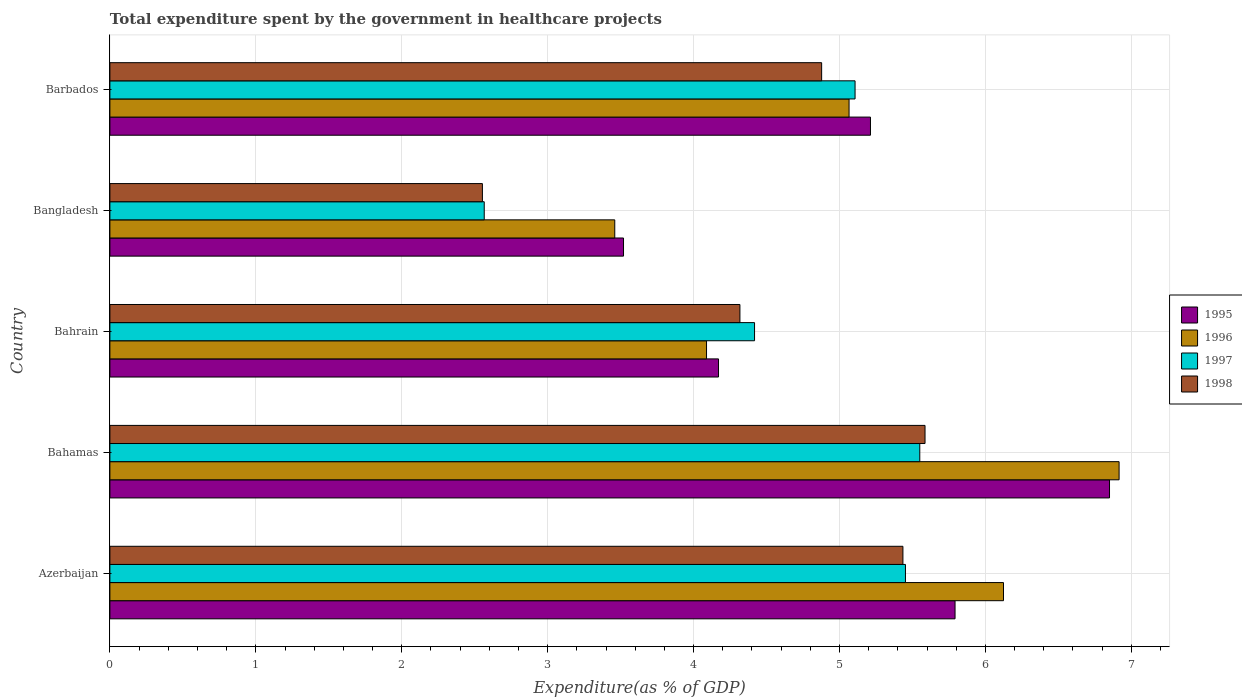Are the number of bars per tick equal to the number of legend labels?
Give a very brief answer. Yes. What is the label of the 4th group of bars from the top?
Offer a very short reply. Bahamas. What is the total expenditure spent by the government in healthcare projects in 1998 in Azerbaijan?
Your answer should be compact. 5.43. Across all countries, what is the maximum total expenditure spent by the government in healthcare projects in 1996?
Provide a short and direct response. 6.92. Across all countries, what is the minimum total expenditure spent by the government in healthcare projects in 1995?
Provide a succinct answer. 3.52. In which country was the total expenditure spent by the government in healthcare projects in 1998 maximum?
Ensure brevity in your answer.  Bahamas. What is the total total expenditure spent by the government in healthcare projects in 1998 in the graph?
Offer a terse response. 22.77. What is the difference between the total expenditure spent by the government in healthcare projects in 1995 in Bahamas and that in Barbados?
Make the answer very short. 1.64. What is the difference between the total expenditure spent by the government in healthcare projects in 1998 in Azerbaijan and the total expenditure spent by the government in healthcare projects in 1995 in Barbados?
Ensure brevity in your answer.  0.22. What is the average total expenditure spent by the government in healthcare projects in 1998 per country?
Provide a short and direct response. 4.55. What is the difference between the total expenditure spent by the government in healthcare projects in 1995 and total expenditure spent by the government in healthcare projects in 1996 in Bahamas?
Make the answer very short. -0.07. In how many countries, is the total expenditure spent by the government in healthcare projects in 1998 greater than 5.6 %?
Provide a short and direct response. 0. What is the ratio of the total expenditure spent by the government in healthcare projects in 1998 in Bahamas to that in Barbados?
Your answer should be very brief. 1.15. Is the total expenditure spent by the government in healthcare projects in 1996 in Bangladesh less than that in Barbados?
Offer a very short reply. Yes. What is the difference between the highest and the second highest total expenditure spent by the government in healthcare projects in 1997?
Provide a succinct answer. 0.1. What is the difference between the highest and the lowest total expenditure spent by the government in healthcare projects in 1995?
Offer a very short reply. 3.33. How many bars are there?
Offer a terse response. 20. Are the values on the major ticks of X-axis written in scientific E-notation?
Make the answer very short. No. Does the graph contain any zero values?
Keep it short and to the point. No. Where does the legend appear in the graph?
Your response must be concise. Center right. How many legend labels are there?
Provide a succinct answer. 4. How are the legend labels stacked?
Offer a very short reply. Vertical. What is the title of the graph?
Keep it short and to the point. Total expenditure spent by the government in healthcare projects. What is the label or title of the X-axis?
Offer a terse response. Expenditure(as % of GDP). What is the label or title of the Y-axis?
Keep it short and to the point. Country. What is the Expenditure(as % of GDP) in 1995 in Azerbaijan?
Provide a short and direct response. 5.79. What is the Expenditure(as % of GDP) in 1996 in Azerbaijan?
Offer a very short reply. 6.12. What is the Expenditure(as % of GDP) in 1997 in Azerbaijan?
Provide a succinct answer. 5.45. What is the Expenditure(as % of GDP) of 1998 in Azerbaijan?
Ensure brevity in your answer.  5.43. What is the Expenditure(as % of GDP) in 1995 in Bahamas?
Make the answer very short. 6.85. What is the Expenditure(as % of GDP) of 1996 in Bahamas?
Your response must be concise. 6.92. What is the Expenditure(as % of GDP) of 1997 in Bahamas?
Give a very brief answer. 5.55. What is the Expenditure(as % of GDP) in 1998 in Bahamas?
Ensure brevity in your answer.  5.59. What is the Expenditure(as % of GDP) of 1995 in Bahrain?
Offer a terse response. 4.17. What is the Expenditure(as % of GDP) of 1996 in Bahrain?
Ensure brevity in your answer.  4.09. What is the Expenditure(as % of GDP) in 1997 in Bahrain?
Keep it short and to the point. 4.42. What is the Expenditure(as % of GDP) of 1998 in Bahrain?
Your answer should be very brief. 4.32. What is the Expenditure(as % of GDP) of 1995 in Bangladesh?
Offer a very short reply. 3.52. What is the Expenditure(as % of GDP) in 1996 in Bangladesh?
Your response must be concise. 3.46. What is the Expenditure(as % of GDP) of 1997 in Bangladesh?
Make the answer very short. 2.57. What is the Expenditure(as % of GDP) in 1998 in Bangladesh?
Your answer should be very brief. 2.55. What is the Expenditure(as % of GDP) in 1995 in Barbados?
Your answer should be very brief. 5.21. What is the Expenditure(as % of GDP) of 1996 in Barbados?
Your answer should be very brief. 5.07. What is the Expenditure(as % of GDP) of 1997 in Barbados?
Your answer should be very brief. 5.11. What is the Expenditure(as % of GDP) of 1998 in Barbados?
Your answer should be very brief. 4.88. Across all countries, what is the maximum Expenditure(as % of GDP) in 1995?
Offer a terse response. 6.85. Across all countries, what is the maximum Expenditure(as % of GDP) of 1996?
Your response must be concise. 6.92. Across all countries, what is the maximum Expenditure(as % of GDP) of 1997?
Make the answer very short. 5.55. Across all countries, what is the maximum Expenditure(as % of GDP) of 1998?
Give a very brief answer. 5.59. Across all countries, what is the minimum Expenditure(as % of GDP) of 1995?
Your answer should be very brief. 3.52. Across all countries, what is the minimum Expenditure(as % of GDP) of 1996?
Keep it short and to the point. 3.46. Across all countries, what is the minimum Expenditure(as % of GDP) in 1997?
Your answer should be very brief. 2.57. Across all countries, what is the minimum Expenditure(as % of GDP) in 1998?
Your answer should be very brief. 2.55. What is the total Expenditure(as % of GDP) in 1995 in the graph?
Provide a short and direct response. 25.55. What is the total Expenditure(as % of GDP) in 1996 in the graph?
Your answer should be compact. 25.65. What is the total Expenditure(as % of GDP) in 1997 in the graph?
Ensure brevity in your answer.  23.09. What is the total Expenditure(as % of GDP) of 1998 in the graph?
Ensure brevity in your answer.  22.77. What is the difference between the Expenditure(as % of GDP) in 1995 in Azerbaijan and that in Bahamas?
Your answer should be compact. -1.06. What is the difference between the Expenditure(as % of GDP) in 1996 in Azerbaijan and that in Bahamas?
Offer a very short reply. -0.79. What is the difference between the Expenditure(as % of GDP) of 1997 in Azerbaijan and that in Bahamas?
Give a very brief answer. -0.1. What is the difference between the Expenditure(as % of GDP) of 1998 in Azerbaijan and that in Bahamas?
Your answer should be very brief. -0.15. What is the difference between the Expenditure(as % of GDP) of 1995 in Azerbaijan and that in Bahrain?
Provide a short and direct response. 1.62. What is the difference between the Expenditure(as % of GDP) in 1996 in Azerbaijan and that in Bahrain?
Your response must be concise. 2.04. What is the difference between the Expenditure(as % of GDP) in 1997 in Azerbaijan and that in Bahrain?
Provide a short and direct response. 1.03. What is the difference between the Expenditure(as % of GDP) of 1998 in Azerbaijan and that in Bahrain?
Give a very brief answer. 1.12. What is the difference between the Expenditure(as % of GDP) of 1995 in Azerbaijan and that in Bangladesh?
Ensure brevity in your answer.  2.27. What is the difference between the Expenditure(as % of GDP) in 1996 in Azerbaijan and that in Bangladesh?
Your response must be concise. 2.66. What is the difference between the Expenditure(as % of GDP) in 1997 in Azerbaijan and that in Bangladesh?
Your response must be concise. 2.89. What is the difference between the Expenditure(as % of GDP) of 1998 in Azerbaijan and that in Bangladesh?
Offer a terse response. 2.88. What is the difference between the Expenditure(as % of GDP) of 1995 in Azerbaijan and that in Barbados?
Make the answer very short. 0.58. What is the difference between the Expenditure(as % of GDP) of 1996 in Azerbaijan and that in Barbados?
Your answer should be compact. 1.06. What is the difference between the Expenditure(as % of GDP) in 1997 in Azerbaijan and that in Barbados?
Provide a succinct answer. 0.35. What is the difference between the Expenditure(as % of GDP) in 1998 in Azerbaijan and that in Barbados?
Give a very brief answer. 0.56. What is the difference between the Expenditure(as % of GDP) in 1995 in Bahamas and that in Bahrain?
Provide a short and direct response. 2.68. What is the difference between the Expenditure(as % of GDP) of 1996 in Bahamas and that in Bahrain?
Provide a succinct answer. 2.83. What is the difference between the Expenditure(as % of GDP) of 1997 in Bahamas and that in Bahrain?
Offer a terse response. 1.13. What is the difference between the Expenditure(as % of GDP) of 1998 in Bahamas and that in Bahrain?
Offer a very short reply. 1.27. What is the difference between the Expenditure(as % of GDP) in 1995 in Bahamas and that in Bangladesh?
Provide a short and direct response. 3.33. What is the difference between the Expenditure(as % of GDP) in 1996 in Bahamas and that in Bangladesh?
Your response must be concise. 3.46. What is the difference between the Expenditure(as % of GDP) in 1997 in Bahamas and that in Bangladesh?
Give a very brief answer. 2.98. What is the difference between the Expenditure(as % of GDP) in 1998 in Bahamas and that in Bangladesh?
Your response must be concise. 3.03. What is the difference between the Expenditure(as % of GDP) of 1995 in Bahamas and that in Barbados?
Keep it short and to the point. 1.64. What is the difference between the Expenditure(as % of GDP) in 1996 in Bahamas and that in Barbados?
Your answer should be compact. 1.85. What is the difference between the Expenditure(as % of GDP) of 1997 in Bahamas and that in Barbados?
Provide a succinct answer. 0.44. What is the difference between the Expenditure(as % of GDP) in 1998 in Bahamas and that in Barbados?
Provide a short and direct response. 0.71. What is the difference between the Expenditure(as % of GDP) of 1995 in Bahrain and that in Bangladesh?
Make the answer very short. 0.65. What is the difference between the Expenditure(as % of GDP) in 1996 in Bahrain and that in Bangladesh?
Your answer should be compact. 0.63. What is the difference between the Expenditure(as % of GDP) in 1997 in Bahrain and that in Bangladesh?
Provide a short and direct response. 1.85. What is the difference between the Expenditure(as % of GDP) of 1998 in Bahrain and that in Bangladesh?
Ensure brevity in your answer.  1.76. What is the difference between the Expenditure(as % of GDP) in 1995 in Bahrain and that in Barbados?
Offer a very short reply. -1.04. What is the difference between the Expenditure(as % of GDP) of 1996 in Bahrain and that in Barbados?
Your answer should be very brief. -0.98. What is the difference between the Expenditure(as % of GDP) in 1997 in Bahrain and that in Barbados?
Your answer should be very brief. -0.69. What is the difference between the Expenditure(as % of GDP) in 1998 in Bahrain and that in Barbados?
Give a very brief answer. -0.56. What is the difference between the Expenditure(as % of GDP) in 1995 in Bangladesh and that in Barbados?
Your response must be concise. -1.69. What is the difference between the Expenditure(as % of GDP) of 1996 in Bangladesh and that in Barbados?
Offer a very short reply. -1.61. What is the difference between the Expenditure(as % of GDP) in 1997 in Bangladesh and that in Barbados?
Your response must be concise. -2.54. What is the difference between the Expenditure(as % of GDP) of 1998 in Bangladesh and that in Barbados?
Give a very brief answer. -2.32. What is the difference between the Expenditure(as % of GDP) in 1995 in Azerbaijan and the Expenditure(as % of GDP) in 1996 in Bahamas?
Your answer should be compact. -1.12. What is the difference between the Expenditure(as % of GDP) in 1995 in Azerbaijan and the Expenditure(as % of GDP) in 1997 in Bahamas?
Offer a very short reply. 0.24. What is the difference between the Expenditure(as % of GDP) of 1995 in Azerbaijan and the Expenditure(as % of GDP) of 1998 in Bahamas?
Your answer should be very brief. 0.21. What is the difference between the Expenditure(as % of GDP) of 1996 in Azerbaijan and the Expenditure(as % of GDP) of 1997 in Bahamas?
Your response must be concise. 0.57. What is the difference between the Expenditure(as % of GDP) in 1996 in Azerbaijan and the Expenditure(as % of GDP) in 1998 in Bahamas?
Provide a short and direct response. 0.54. What is the difference between the Expenditure(as % of GDP) of 1997 in Azerbaijan and the Expenditure(as % of GDP) of 1998 in Bahamas?
Your response must be concise. -0.13. What is the difference between the Expenditure(as % of GDP) in 1995 in Azerbaijan and the Expenditure(as % of GDP) in 1996 in Bahrain?
Ensure brevity in your answer.  1.7. What is the difference between the Expenditure(as % of GDP) of 1995 in Azerbaijan and the Expenditure(as % of GDP) of 1997 in Bahrain?
Keep it short and to the point. 1.37. What is the difference between the Expenditure(as % of GDP) of 1995 in Azerbaijan and the Expenditure(as % of GDP) of 1998 in Bahrain?
Keep it short and to the point. 1.47. What is the difference between the Expenditure(as % of GDP) in 1996 in Azerbaijan and the Expenditure(as % of GDP) in 1997 in Bahrain?
Offer a terse response. 1.71. What is the difference between the Expenditure(as % of GDP) in 1996 in Azerbaijan and the Expenditure(as % of GDP) in 1998 in Bahrain?
Provide a succinct answer. 1.81. What is the difference between the Expenditure(as % of GDP) in 1997 in Azerbaijan and the Expenditure(as % of GDP) in 1998 in Bahrain?
Give a very brief answer. 1.13. What is the difference between the Expenditure(as % of GDP) in 1995 in Azerbaijan and the Expenditure(as % of GDP) in 1996 in Bangladesh?
Offer a very short reply. 2.33. What is the difference between the Expenditure(as % of GDP) of 1995 in Azerbaijan and the Expenditure(as % of GDP) of 1997 in Bangladesh?
Provide a succinct answer. 3.23. What is the difference between the Expenditure(as % of GDP) of 1995 in Azerbaijan and the Expenditure(as % of GDP) of 1998 in Bangladesh?
Give a very brief answer. 3.24. What is the difference between the Expenditure(as % of GDP) in 1996 in Azerbaijan and the Expenditure(as % of GDP) in 1997 in Bangladesh?
Your response must be concise. 3.56. What is the difference between the Expenditure(as % of GDP) in 1996 in Azerbaijan and the Expenditure(as % of GDP) in 1998 in Bangladesh?
Offer a very short reply. 3.57. What is the difference between the Expenditure(as % of GDP) in 1997 in Azerbaijan and the Expenditure(as % of GDP) in 1998 in Bangladesh?
Give a very brief answer. 2.9. What is the difference between the Expenditure(as % of GDP) of 1995 in Azerbaijan and the Expenditure(as % of GDP) of 1996 in Barbados?
Your answer should be very brief. 0.73. What is the difference between the Expenditure(as % of GDP) of 1995 in Azerbaijan and the Expenditure(as % of GDP) of 1997 in Barbados?
Keep it short and to the point. 0.69. What is the difference between the Expenditure(as % of GDP) of 1995 in Azerbaijan and the Expenditure(as % of GDP) of 1998 in Barbados?
Keep it short and to the point. 0.91. What is the difference between the Expenditure(as % of GDP) of 1996 in Azerbaijan and the Expenditure(as % of GDP) of 1997 in Barbados?
Offer a very short reply. 1.02. What is the difference between the Expenditure(as % of GDP) of 1996 in Azerbaijan and the Expenditure(as % of GDP) of 1998 in Barbados?
Your response must be concise. 1.25. What is the difference between the Expenditure(as % of GDP) of 1997 in Azerbaijan and the Expenditure(as % of GDP) of 1998 in Barbados?
Provide a succinct answer. 0.57. What is the difference between the Expenditure(as % of GDP) in 1995 in Bahamas and the Expenditure(as % of GDP) in 1996 in Bahrain?
Your answer should be compact. 2.76. What is the difference between the Expenditure(as % of GDP) in 1995 in Bahamas and the Expenditure(as % of GDP) in 1997 in Bahrain?
Make the answer very short. 2.43. What is the difference between the Expenditure(as % of GDP) of 1995 in Bahamas and the Expenditure(as % of GDP) of 1998 in Bahrain?
Provide a succinct answer. 2.53. What is the difference between the Expenditure(as % of GDP) of 1996 in Bahamas and the Expenditure(as % of GDP) of 1997 in Bahrain?
Provide a short and direct response. 2.5. What is the difference between the Expenditure(as % of GDP) of 1996 in Bahamas and the Expenditure(as % of GDP) of 1998 in Bahrain?
Give a very brief answer. 2.6. What is the difference between the Expenditure(as % of GDP) in 1997 in Bahamas and the Expenditure(as % of GDP) in 1998 in Bahrain?
Your response must be concise. 1.23. What is the difference between the Expenditure(as % of GDP) of 1995 in Bahamas and the Expenditure(as % of GDP) of 1996 in Bangladesh?
Your answer should be very brief. 3.39. What is the difference between the Expenditure(as % of GDP) in 1995 in Bahamas and the Expenditure(as % of GDP) in 1997 in Bangladesh?
Your answer should be compact. 4.29. What is the difference between the Expenditure(as % of GDP) of 1995 in Bahamas and the Expenditure(as % of GDP) of 1998 in Bangladesh?
Offer a terse response. 4.3. What is the difference between the Expenditure(as % of GDP) of 1996 in Bahamas and the Expenditure(as % of GDP) of 1997 in Bangladesh?
Your response must be concise. 4.35. What is the difference between the Expenditure(as % of GDP) of 1996 in Bahamas and the Expenditure(as % of GDP) of 1998 in Bangladesh?
Ensure brevity in your answer.  4.36. What is the difference between the Expenditure(as % of GDP) in 1997 in Bahamas and the Expenditure(as % of GDP) in 1998 in Bangladesh?
Make the answer very short. 3. What is the difference between the Expenditure(as % of GDP) in 1995 in Bahamas and the Expenditure(as % of GDP) in 1996 in Barbados?
Keep it short and to the point. 1.78. What is the difference between the Expenditure(as % of GDP) of 1995 in Bahamas and the Expenditure(as % of GDP) of 1997 in Barbados?
Keep it short and to the point. 1.74. What is the difference between the Expenditure(as % of GDP) in 1995 in Bahamas and the Expenditure(as % of GDP) in 1998 in Barbados?
Offer a terse response. 1.97. What is the difference between the Expenditure(as % of GDP) in 1996 in Bahamas and the Expenditure(as % of GDP) in 1997 in Barbados?
Offer a very short reply. 1.81. What is the difference between the Expenditure(as % of GDP) in 1996 in Bahamas and the Expenditure(as % of GDP) in 1998 in Barbados?
Your response must be concise. 2.04. What is the difference between the Expenditure(as % of GDP) in 1997 in Bahamas and the Expenditure(as % of GDP) in 1998 in Barbados?
Your answer should be very brief. 0.67. What is the difference between the Expenditure(as % of GDP) of 1995 in Bahrain and the Expenditure(as % of GDP) of 1996 in Bangladesh?
Give a very brief answer. 0.71. What is the difference between the Expenditure(as % of GDP) in 1995 in Bahrain and the Expenditure(as % of GDP) in 1997 in Bangladesh?
Give a very brief answer. 1.61. What is the difference between the Expenditure(as % of GDP) of 1995 in Bahrain and the Expenditure(as % of GDP) of 1998 in Bangladesh?
Give a very brief answer. 1.62. What is the difference between the Expenditure(as % of GDP) in 1996 in Bahrain and the Expenditure(as % of GDP) in 1997 in Bangladesh?
Offer a very short reply. 1.52. What is the difference between the Expenditure(as % of GDP) in 1996 in Bahrain and the Expenditure(as % of GDP) in 1998 in Bangladesh?
Ensure brevity in your answer.  1.54. What is the difference between the Expenditure(as % of GDP) in 1997 in Bahrain and the Expenditure(as % of GDP) in 1998 in Bangladesh?
Keep it short and to the point. 1.86. What is the difference between the Expenditure(as % of GDP) in 1995 in Bahrain and the Expenditure(as % of GDP) in 1996 in Barbados?
Ensure brevity in your answer.  -0.89. What is the difference between the Expenditure(as % of GDP) in 1995 in Bahrain and the Expenditure(as % of GDP) in 1997 in Barbados?
Make the answer very short. -0.94. What is the difference between the Expenditure(as % of GDP) of 1995 in Bahrain and the Expenditure(as % of GDP) of 1998 in Barbados?
Offer a terse response. -0.71. What is the difference between the Expenditure(as % of GDP) of 1996 in Bahrain and the Expenditure(as % of GDP) of 1997 in Barbados?
Offer a terse response. -1.02. What is the difference between the Expenditure(as % of GDP) in 1996 in Bahrain and the Expenditure(as % of GDP) in 1998 in Barbados?
Offer a very short reply. -0.79. What is the difference between the Expenditure(as % of GDP) in 1997 in Bahrain and the Expenditure(as % of GDP) in 1998 in Barbados?
Your response must be concise. -0.46. What is the difference between the Expenditure(as % of GDP) of 1995 in Bangladesh and the Expenditure(as % of GDP) of 1996 in Barbados?
Give a very brief answer. -1.55. What is the difference between the Expenditure(as % of GDP) in 1995 in Bangladesh and the Expenditure(as % of GDP) in 1997 in Barbados?
Keep it short and to the point. -1.59. What is the difference between the Expenditure(as % of GDP) of 1995 in Bangladesh and the Expenditure(as % of GDP) of 1998 in Barbados?
Keep it short and to the point. -1.36. What is the difference between the Expenditure(as % of GDP) of 1996 in Bangladesh and the Expenditure(as % of GDP) of 1997 in Barbados?
Provide a succinct answer. -1.65. What is the difference between the Expenditure(as % of GDP) of 1996 in Bangladesh and the Expenditure(as % of GDP) of 1998 in Barbados?
Ensure brevity in your answer.  -1.42. What is the difference between the Expenditure(as % of GDP) of 1997 in Bangladesh and the Expenditure(as % of GDP) of 1998 in Barbados?
Offer a terse response. -2.31. What is the average Expenditure(as % of GDP) of 1995 per country?
Provide a short and direct response. 5.11. What is the average Expenditure(as % of GDP) of 1996 per country?
Ensure brevity in your answer.  5.13. What is the average Expenditure(as % of GDP) of 1997 per country?
Your response must be concise. 4.62. What is the average Expenditure(as % of GDP) in 1998 per country?
Make the answer very short. 4.55. What is the difference between the Expenditure(as % of GDP) of 1995 and Expenditure(as % of GDP) of 1996 in Azerbaijan?
Keep it short and to the point. -0.33. What is the difference between the Expenditure(as % of GDP) of 1995 and Expenditure(as % of GDP) of 1997 in Azerbaijan?
Your answer should be compact. 0.34. What is the difference between the Expenditure(as % of GDP) of 1995 and Expenditure(as % of GDP) of 1998 in Azerbaijan?
Make the answer very short. 0.36. What is the difference between the Expenditure(as % of GDP) of 1996 and Expenditure(as % of GDP) of 1997 in Azerbaijan?
Your answer should be compact. 0.67. What is the difference between the Expenditure(as % of GDP) of 1996 and Expenditure(as % of GDP) of 1998 in Azerbaijan?
Give a very brief answer. 0.69. What is the difference between the Expenditure(as % of GDP) of 1997 and Expenditure(as % of GDP) of 1998 in Azerbaijan?
Provide a succinct answer. 0.02. What is the difference between the Expenditure(as % of GDP) of 1995 and Expenditure(as % of GDP) of 1996 in Bahamas?
Keep it short and to the point. -0.07. What is the difference between the Expenditure(as % of GDP) in 1995 and Expenditure(as % of GDP) in 1997 in Bahamas?
Your response must be concise. 1.3. What is the difference between the Expenditure(as % of GDP) in 1995 and Expenditure(as % of GDP) in 1998 in Bahamas?
Your response must be concise. 1.26. What is the difference between the Expenditure(as % of GDP) in 1996 and Expenditure(as % of GDP) in 1997 in Bahamas?
Ensure brevity in your answer.  1.37. What is the difference between the Expenditure(as % of GDP) in 1996 and Expenditure(as % of GDP) in 1998 in Bahamas?
Your answer should be compact. 1.33. What is the difference between the Expenditure(as % of GDP) of 1997 and Expenditure(as % of GDP) of 1998 in Bahamas?
Your response must be concise. -0.04. What is the difference between the Expenditure(as % of GDP) of 1995 and Expenditure(as % of GDP) of 1996 in Bahrain?
Make the answer very short. 0.08. What is the difference between the Expenditure(as % of GDP) in 1995 and Expenditure(as % of GDP) in 1997 in Bahrain?
Make the answer very short. -0.25. What is the difference between the Expenditure(as % of GDP) in 1995 and Expenditure(as % of GDP) in 1998 in Bahrain?
Provide a succinct answer. -0.15. What is the difference between the Expenditure(as % of GDP) in 1996 and Expenditure(as % of GDP) in 1997 in Bahrain?
Ensure brevity in your answer.  -0.33. What is the difference between the Expenditure(as % of GDP) in 1996 and Expenditure(as % of GDP) in 1998 in Bahrain?
Your answer should be very brief. -0.23. What is the difference between the Expenditure(as % of GDP) of 1997 and Expenditure(as % of GDP) of 1998 in Bahrain?
Offer a very short reply. 0.1. What is the difference between the Expenditure(as % of GDP) of 1995 and Expenditure(as % of GDP) of 1996 in Bangladesh?
Give a very brief answer. 0.06. What is the difference between the Expenditure(as % of GDP) in 1995 and Expenditure(as % of GDP) in 1997 in Bangladesh?
Your answer should be very brief. 0.95. What is the difference between the Expenditure(as % of GDP) in 1996 and Expenditure(as % of GDP) in 1997 in Bangladesh?
Offer a very short reply. 0.89. What is the difference between the Expenditure(as % of GDP) in 1996 and Expenditure(as % of GDP) in 1998 in Bangladesh?
Ensure brevity in your answer.  0.91. What is the difference between the Expenditure(as % of GDP) in 1997 and Expenditure(as % of GDP) in 1998 in Bangladesh?
Give a very brief answer. 0.01. What is the difference between the Expenditure(as % of GDP) in 1995 and Expenditure(as % of GDP) in 1996 in Barbados?
Offer a terse response. 0.15. What is the difference between the Expenditure(as % of GDP) in 1995 and Expenditure(as % of GDP) in 1997 in Barbados?
Offer a terse response. 0.11. What is the difference between the Expenditure(as % of GDP) of 1995 and Expenditure(as % of GDP) of 1998 in Barbados?
Offer a very short reply. 0.33. What is the difference between the Expenditure(as % of GDP) in 1996 and Expenditure(as % of GDP) in 1997 in Barbados?
Give a very brief answer. -0.04. What is the difference between the Expenditure(as % of GDP) in 1996 and Expenditure(as % of GDP) in 1998 in Barbados?
Your answer should be very brief. 0.19. What is the difference between the Expenditure(as % of GDP) in 1997 and Expenditure(as % of GDP) in 1998 in Barbados?
Offer a terse response. 0.23. What is the ratio of the Expenditure(as % of GDP) of 1995 in Azerbaijan to that in Bahamas?
Your answer should be very brief. 0.85. What is the ratio of the Expenditure(as % of GDP) of 1996 in Azerbaijan to that in Bahamas?
Offer a very short reply. 0.89. What is the ratio of the Expenditure(as % of GDP) in 1997 in Azerbaijan to that in Bahamas?
Your answer should be very brief. 0.98. What is the ratio of the Expenditure(as % of GDP) in 1998 in Azerbaijan to that in Bahamas?
Ensure brevity in your answer.  0.97. What is the ratio of the Expenditure(as % of GDP) in 1995 in Azerbaijan to that in Bahrain?
Your answer should be very brief. 1.39. What is the ratio of the Expenditure(as % of GDP) of 1996 in Azerbaijan to that in Bahrain?
Your answer should be compact. 1.5. What is the ratio of the Expenditure(as % of GDP) in 1997 in Azerbaijan to that in Bahrain?
Provide a succinct answer. 1.23. What is the ratio of the Expenditure(as % of GDP) of 1998 in Azerbaijan to that in Bahrain?
Your response must be concise. 1.26. What is the ratio of the Expenditure(as % of GDP) in 1995 in Azerbaijan to that in Bangladesh?
Your answer should be compact. 1.65. What is the ratio of the Expenditure(as % of GDP) in 1996 in Azerbaijan to that in Bangladesh?
Make the answer very short. 1.77. What is the ratio of the Expenditure(as % of GDP) of 1997 in Azerbaijan to that in Bangladesh?
Your answer should be compact. 2.13. What is the ratio of the Expenditure(as % of GDP) of 1998 in Azerbaijan to that in Bangladesh?
Offer a very short reply. 2.13. What is the ratio of the Expenditure(as % of GDP) of 1995 in Azerbaijan to that in Barbados?
Your response must be concise. 1.11. What is the ratio of the Expenditure(as % of GDP) of 1996 in Azerbaijan to that in Barbados?
Your answer should be compact. 1.21. What is the ratio of the Expenditure(as % of GDP) of 1997 in Azerbaijan to that in Barbados?
Your response must be concise. 1.07. What is the ratio of the Expenditure(as % of GDP) of 1998 in Azerbaijan to that in Barbados?
Offer a very short reply. 1.11. What is the ratio of the Expenditure(as % of GDP) in 1995 in Bahamas to that in Bahrain?
Ensure brevity in your answer.  1.64. What is the ratio of the Expenditure(as % of GDP) of 1996 in Bahamas to that in Bahrain?
Offer a terse response. 1.69. What is the ratio of the Expenditure(as % of GDP) of 1997 in Bahamas to that in Bahrain?
Offer a very short reply. 1.26. What is the ratio of the Expenditure(as % of GDP) in 1998 in Bahamas to that in Bahrain?
Ensure brevity in your answer.  1.29. What is the ratio of the Expenditure(as % of GDP) of 1995 in Bahamas to that in Bangladesh?
Offer a very short reply. 1.95. What is the ratio of the Expenditure(as % of GDP) of 1996 in Bahamas to that in Bangladesh?
Provide a succinct answer. 2. What is the ratio of the Expenditure(as % of GDP) in 1997 in Bahamas to that in Bangladesh?
Ensure brevity in your answer.  2.16. What is the ratio of the Expenditure(as % of GDP) in 1998 in Bahamas to that in Bangladesh?
Keep it short and to the point. 2.19. What is the ratio of the Expenditure(as % of GDP) of 1995 in Bahamas to that in Barbados?
Offer a terse response. 1.31. What is the ratio of the Expenditure(as % of GDP) of 1996 in Bahamas to that in Barbados?
Provide a succinct answer. 1.37. What is the ratio of the Expenditure(as % of GDP) in 1997 in Bahamas to that in Barbados?
Keep it short and to the point. 1.09. What is the ratio of the Expenditure(as % of GDP) in 1998 in Bahamas to that in Barbados?
Your answer should be compact. 1.15. What is the ratio of the Expenditure(as % of GDP) of 1995 in Bahrain to that in Bangladesh?
Offer a terse response. 1.19. What is the ratio of the Expenditure(as % of GDP) in 1996 in Bahrain to that in Bangladesh?
Keep it short and to the point. 1.18. What is the ratio of the Expenditure(as % of GDP) of 1997 in Bahrain to that in Bangladesh?
Your answer should be very brief. 1.72. What is the ratio of the Expenditure(as % of GDP) in 1998 in Bahrain to that in Bangladesh?
Your answer should be compact. 1.69. What is the ratio of the Expenditure(as % of GDP) of 1995 in Bahrain to that in Barbados?
Keep it short and to the point. 0.8. What is the ratio of the Expenditure(as % of GDP) in 1996 in Bahrain to that in Barbados?
Keep it short and to the point. 0.81. What is the ratio of the Expenditure(as % of GDP) in 1997 in Bahrain to that in Barbados?
Your answer should be compact. 0.87. What is the ratio of the Expenditure(as % of GDP) in 1998 in Bahrain to that in Barbados?
Provide a short and direct response. 0.89. What is the ratio of the Expenditure(as % of GDP) of 1995 in Bangladesh to that in Barbados?
Provide a succinct answer. 0.68. What is the ratio of the Expenditure(as % of GDP) in 1996 in Bangladesh to that in Barbados?
Your answer should be very brief. 0.68. What is the ratio of the Expenditure(as % of GDP) in 1997 in Bangladesh to that in Barbados?
Make the answer very short. 0.5. What is the ratio of the Expenditure(as % of GDP) of 1998 in Bangladesh to that in Barbados?
Keep it short and to the point. 0.52. What is the difference between the highest and the second highest Expenditure(as % of GDP) in 1995?
Give a very brief answer. 1.06. What is the difference between the highest and the second highest Expenditure(as % of GDP) in 1996?
Provide a short and direct response. 0.79. What is the difference between the highest and the second highest Expenditure(as % of GDP) of 1997?
Give a very brief answer. 0.1. What is the difference between the highest and the second highest Expenditure(as % of GDP) of 1998?
Offer a very short reply. 0.15. What is the difference between the highest and the lowest Expenditure(as % of GDP) in 1995?
Your answer should be compact. 3.33. What is the difference between the highest and the lowest Expenditure(as % of GDP) of 1996?
Give a very brief answer. 3.46. What is the difference between the highest and the lowest Expenditure(as % of GDP) in 1997?
Your response must be concise. 2.98. What is the difference between the highest and the lowest Expenditure(as % of GDP) in 1998?
Offer a terse response. 3.03. 